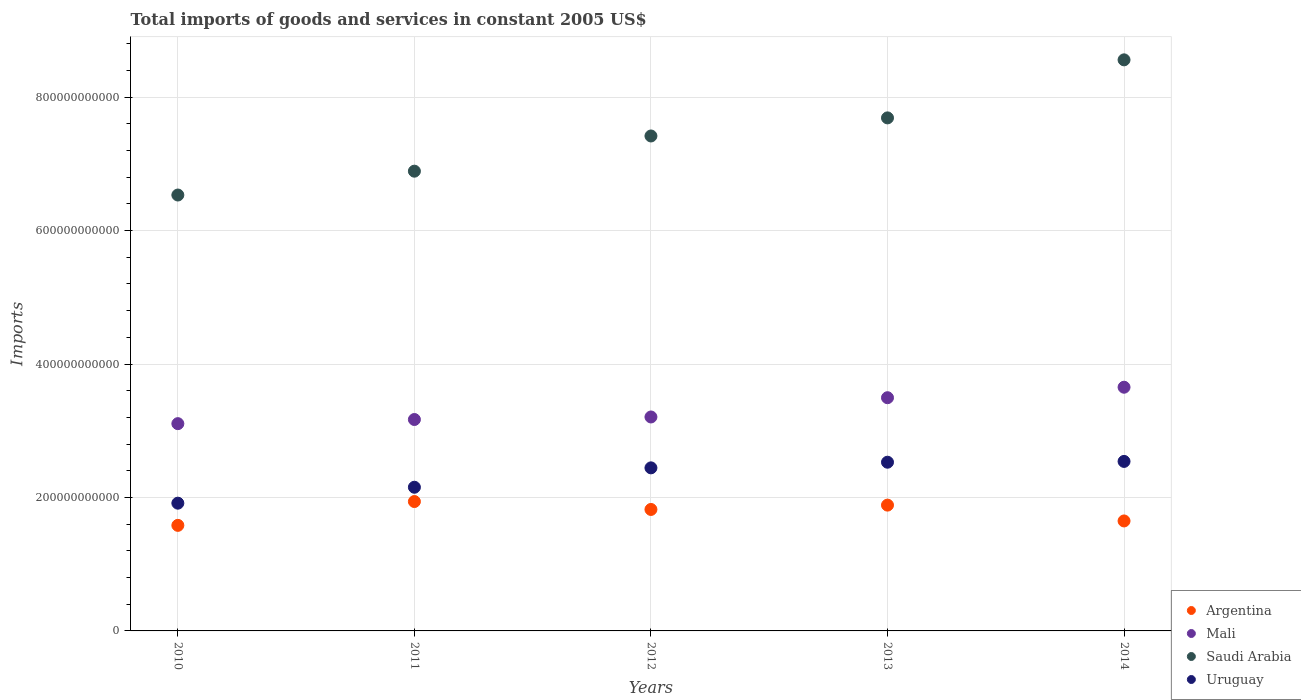Is the number of dotlines equal to the number of legend labels?
Offer a terse response. Yes. What is the total imports of goods and services in Mali in 2013?
Your response must be concise. 3.49e+11. Across all years, what is the maximum total imports of goods and services in Argentina?
Offer a very short reply. 1.94e+11. Across all years, what is the minimum total imports of goods and services in Uruguay?
Make the answer very short. 1.91e+11. What is the total total imports of goods and services in Saudi Arabia in the graph?
Your answer should be compact. 3.71e+12. What is the difference between the total imports of goods and services in Saudi Arabia in 2011 and that in 2013?
Ensure brevity in your answer.  -7.99e+1. What is the difference between the total imports of goods and services in Mali in 2011 and the total imports of goods and services in Saudi Arabia in 2013?
Your answer should be compact. -4.52e+11. What is the average total imports of goods and services in Argentina per year?
Ensure brevity in your answer.  1.77e+11. In the year 2011, what is the difference between the total imports of goods and services in Argentina and total imports of goods and services in Uruguay?
Offer a terse response. -2.14e+1. What is the ratio of the total imports of goods and services in Saudi Arabia in 2011 to that in 2012?
Keep it short and to the point. 0.93. Is the difference between the total imports of goods and services in Argentina in 2011 and 2014 greater than the difference between the total imports of goods and services in Uruguay in 2011 and 2014?
Your response must be concise. Yes. What is the difference between the highest and the second highest total imports of goods and services in Mali?
Your response must be concise. 1.57e+1. What is the difference between the highest and the lowest total imports of goods and services in Saudi Arabia?
Your answer should be compact. 2.03e+11. In how many years, is the total imports of goods and services in Mali greater than the average total imports of goods and services in Mali taken over all years?
Provide a succinct answer. 2. Is it the case that in every year, the sum of the total imports of goods and services in Saudi Arabia and total imports of goods and services in Uruguay  is greater than the sum of total imports of goods and services in Mali and total imports of goods and services in Argentina?
Keep it short and to the point. Yes. Is it the case that in every year, the sum of the total imports of goods and services in Uruguay and total imports of goods and services in Argentina  is greater than the total imports of goods and services in Mali?
Give a very brief answer. Yes. Does the total imports of goods and services in Argentina monotonically increase over the years?
Keep it short and to the point. No. Is the total imports of goods and services in Argentina strictly greater than the total imports of goods and services in Uruguay over the years?
Keep it short and to the point. No. How many dotlines are there?
Provide a short and direct response. 4. How many years are there in the graph?
Your response must be concise. 5. What is the difference between two consecutive major ticks on the Y-axis?
Your answer should be very brief. 2.00e+11. Does the graph contain grids?
Provide a succinct answer. Yes. How many legend labels are there?
Keep it short and to the point. 4. What is the title of the graph?
Give a very brief answer. Total imports of goods and services in constant 2005 US$. What is the label or title of the X-axis?
Ensure brevity in your answer.  Years. What is the label or title of the Y-axis?
Offer a terse response. Imports. What is the Imports of Argentina in 2010?
Provide a succinct answer. 1.58e+11. What is the Imports in Mali in 2010?
Ensure brevity in your answer.  3.11e+11. What is the Imports of Saudi Arabia in 2010?
Provide a short and direct response. 6.53e+11. What is the Imports in Uruguay in 2010?
Provide a succinct answer. 1.91e+11. What is the Imports of Argentina in 2011?
Give a very brief answer. 1.94e+11. What is the Imports in Mali in 2011?
Provide a succinct answer. 3.17e+11. What is the Imports of Saudi Arabia in 2011?
Offer a very short reply. 6.89e+11. What is the Imports of Uruguay in 2011?
Offer a terse response. 2.15e+11. What is the Imports of Argentina in 2012?
Your answer should be very brief. 1.82e+11. What is the Imports of Mali in 2012?
Give a very brief answer. 3.21e+11. What is the Imports of Saudi Arabia in 2012?
Ensure brevity in your answer.  7.42e+11. What is the Imports of Uruguay in 2012?
Your answer should be very brief. 2.44e+11. What is the Imports of Argentina in 2013?
Give a very brief answer. 1.89e+11. What is the Imports in Mali in 2013?
Your answer should be very brief. 3.49e+11. What is the Imports in Saudi Arabia in 2013?
Your response must be concise. 7.69e+11. What is the Imports of Uruguay in 2013?
Keep it short and to the point. 2.53e+11. What is the Imports of Argentina in 2014?
Keep it short and to the point. 1.65e+11. What is the Imports in Mali in 2014?
Offer a very short reply. 3.65e+11. What is the Imports in Saudi Arabia in 2014?
Offer a very short reply. 8.56e+11. What is the Imports of Uruguay in 2014?
Ensure brevity in your answer.  2.54e+11. Across all years, what is the maximum Imports of Argentina?
Provide a succinct answer. 1.94e+11. Across all years, what is the maximum Imports in Mali?
Your answer should be compact. 3.65e+11. Across all years, what is the maximum Imports in Saudi Arabia?
Your answer should be very brief. 8.56e+11. Across all years, what is the maximum Imports of Uruguay?
Your answer should be very brief. 2.54e+11. Across all years, what is the minimum Imports of Argentina?
Your answer should be very brief. 1.58e+11. Across all years, what is the minimum Imports in Mali?
Ensure brevity in your answer.  3.11e+11. Across all years, what is the minimum Imports of Saudi Arabia?
Your answer should be compact. 6.53e+11. Across all years, what is the minimum Imports of Uruguay?
Make the answer very short. 1.91e+11. What is the total Imports in Argentina in the graph?
Provide a succinct answer. 8.87e+11. What is the total Imports of Mali in the graph?
Ensure brevity in your answer.  1.66e+12. What is the total Imports in Saudi Arabia in the graph?
Provide a succinct answer. 3.71e+12. What is the total Imports of Uruguay in the graph?
Offer a very short reply. 1.16e+12. What is the difference between the Imports of Argentina in 2010 and that in 2011?
Provide a succinct answer. -3.57e+1. What is the difference between the Imports of Mali in 2010 and that in 2011?
Keep it short and to the point. -6.21e+09. What is the difference between the Imports in Saudi Arabia in 2010 and that in 2011?
Ensure brevity in your answer.  -3.57e+1. What is the difference between the Imports in Uruguay in 2010 and that in 2011?
Offer a terse response. -2.39e+1. What is the difference between the Imports of Argentina in 2010 and that in 2012?
Provide a short and direct response. -2.38e+1. What is the difference between the Imports in Mali in 2010 and that in 2012?
Your answer should be very brief. -1.00e+1. What is the difference between the Imports of Saudi Arabia in 2010 and that in 2012?
Provide a succinct answer. -8.85e+1. What is the difference between the Imports of Uruguay in 2010 and that in 2012?
Ensure brevity in your answer.  -5.29e+1. What is the difference between the Imports of Argentina in 2010 and that in 2013?
Ensure brevity in your answer.  -3.03e+1. What is the difference between the Imports in Mali in 2010 and that in 2013?
Offer a terse response. -3.89e+1. What is the difference between the Imports of Saudi Arabia in 2010 and that in 2013?
Provide a short and direct response. -1.16e+11. What is the difference between the Imports in Uruguay in 2010 and that in 2013?
Provide a succinct answer. -6.14e+1. What is the difference between the Imports of Argentina in 2010 and that in 2014?
Your response must be concise. -6.62e+09. What is the difference between the Imports of Mali in 2010 and that in 2014?
Provide a short and direct response. -5.46e+1. What is the difference between the Imports of Saudi Arabia in 2010 and that in 2014?
Keep it short and to the point. -2.03e+11. What is the difference between the Imports in Uruguay in 2010 and that in 2014?
Offer a terse response. -6.26e+1. What is the difference between the Imports of Argentina in 2011 and that in 2012?
Your answer should be compact. 1.19e+1. What is the difference between the Imports of Mali in 2011 and that in 2012?
Provide a succinct answer. -3.80e+09. What is the difference between the Imports in Saudi Arabia in 2011 and that in 2012?
Your response must be concise. -5.28e+1. What is the difference between the Imports of Uruguay in 2011 and that in 2012?
Keep it short and to the point. -2.91e+1. What is the difference between the Imports in Argentina in 2011 and that in 2013?
Offer a very short reply. 5.37e+09. What is the difference between the Imports of Mali in 2011 and that in 2013?
Make the answer very short. -3.27e+1. What is the difference between the Imports in Saudi Arabia in 2011 and that in 2013?
Give a very brief answer. -7.99e+1. What is the difference between the Imports in Uruguay in 2011 and that in 2013?
Your answer should be very brief. -3.75e+1. What is the difference between the Imports in Argentina in 2011 and that in 2014?
Give a very brief answer. 2.91e+1. What is the difference between the Imports in Mali in 2011 and that in 2014?
Your answer should be compact. -4.84e+1. What is the difference between the Imports of Saudi Arabia in 2011 and that in 2014?
Keep it short and to the point. -1.67e+11. What is the difference between the Imports in Uruguay in 2011 and that in 2014?
Keep it short and to the point. -3.87e+1. What is the difference between the Imports in Argentina in 2012 and that in 2013?
Give a very brief answer. -6.49e+09. What is the difference between the Imports of Mali in 2012 and that in 2013?
Your response must be concise. -2.89e+1. What is the difference between the Imports of Saudi Arabia in 2012 and that in 2013?
Your response must be concise. -2.71e+1. What is the difference between the Imports of Uruguay in 2012 and that in 2013?
Offer a terse response. -8.46e+09. What is the difference between the Imports in Argentina in 2012 and that in 2014?
Your answer should be compact. 1.72e+1. What is the difference between the Imports of Mali in 2012 and that in 2014?
Provide a short and direct response. -4.46e+1. What is the difference between the Imports of Saudi Arabia in 2012 and that in 2014?
Your answer should be compact. -1.14e+11. What is the difference between the Imports in Uruguay in 2012 and that in 2014?
Your answer should be compact. -9.66e+09. What is the difference between the Imports of Argentina in 2013 and that in 2014?
Make the answer very short. 2.37e+1. What is the difference between the Imports in Mali in 2013 and that in 2014?
Your answer should be very brief. -1.57e+1. What is the difference between the Imports of Saudi Arabia in 2013 and that in 2014?
Make the answer very short. -8.70e+1. What is the difference between the Imports in Uruguay in 2013 and that in 2014?
Provide a succinct answer. -1.20e+09. What is the difference between the Imports in Argentina in 2010 and the Imports in Mali in 2011?
Provide a succinct answer. -1.59e+11. What is the difference between the Imports of Argentina in 2010 and the Imports of Saudi Arabia in 2011?
Your response must be concise. -5.31e+11. What is the difference between the Imports in Argentina in 2010 and the Imports in Uruguay in 2011?
Your response must be concise. -5.71e+1. What is the difference between the Imports of Mali in 2010 and the Imports of Saudi Arabia in 2011?
Keep it short and to the point. -3.78e+11. What is the difference between the Imports of Mali in 2010 and the Imports of Uruguay in 2011?
Provide a short and direct response. 9.53e+1. What is the difference between the Imports of Saudi Arabia in 2010 and the Imports of Uruguay in 2011?
Keep it short and to the point. 4.38e+11. What is the difference between the Imports in Argentina in 2010 and the Imports in Mali in 2012?
Ensure brevity in your answer.  -1.62e+11. What is the difference between the Imports of Argentina in 2010 and the Imports of Saudi Arabia in 2012?
Your answer should be compact. -5.84e+11. What is the difference between the Imports of Argentina in 2010 and the Imports of Uruguay in 2012?
Your response must be concise. -8.62e+1. What is the difference between the Imports in Mali in 2010 and the Imports in Saudi Arabia in 2012?
Provide a short and direct response. -4.31e+11. What is the difference between the Imports of Mali in 2010 and the Imports of Uruguay in 2012?
Offer a terse response. 6.62e+1. What is the difference between the Imports in Saudi Arabia in 2010 and the Imports in Uruguay in 2012?
Your response must be concise. 4.09e+11. What is the difference between the Imports in Argentina in 2010 and the Imports in Mali in 2013?
Give a very brief answer. -1.91e+11. What is the difference between the Imports of Argentina in 2010 and the Imports of Saudi Arabia in 2013?
Ensure brevity in your answer.  -6.11e+11. What is the difference between the Imports of Argentina in 2010 and the Imports of Uruguay in 2013?
Keep it short and to the point. -9.46e+1. What is the difference between the Imports of Mali in 2010 and the Imports of Saudi Arabia in 2013?
Offer a very short reply. -4.58e+11. What is the difference between the Imports of Mali in 2010 and the Imports of Uruguay in 2013?
Your response must be concise. 5.78e+1. What is the difference between the Imports in Saudi Arabia in 2010 and the Imports in Uruguay in 2013?
Offer a terse response. 4.00e+11. What is the difference between the Imports of Argentina in 2010 and the Imports of Mali in 2014?
Make the answer very short. -2.07e+11. What is the difference between the Imports in Argentina in 2010 and the Imports in Saudi Arabia in 2014?
Provide a succinct answer. -6.98e+11. What is the difference between the Imports of Argentina in 2010 and the Imports of Uruguay in 2014?
Provide a succinct answer. -9.58e+1. What is the difference between the Imports in Mali in 2010 and the Imports in Saudi Arabia in 2014?
Offer a very short reply. -5.45e+11. What is the difference between the Imports in Mali in 2010 and the Imports in Uruguay in 2014?
Provide a succinct answer. 5.66e+1. What is the difference between the Imports of Saudi Arabia in 2010 and the Imports of Uruguay in 2014?
Offer a terse response. 3.99e+11. What is the difference between the Imports of Argentina in 2011 and the Imports of Mali in 2012?
Provide a short and direct response. -1.27e+11. What is the difference between the Imports in Argentina in 2011 and the Imports in Saudi Arabia in 2012?
Provide a succinct answer. -5.48e+11. What is the difference between the Imports in Argentina in 2011 and the Imports in Uruguay in 2012?
Your answer should be compact. -5.05e+1. What is the difference between the Imports in Mali in 2011 and the Imports in Saudi Arabia in 2012?
Make the answer very short. -4.25e+11. What is the difference between the Imports of Mali in 2011 and the Imports of Uruguay in 2012?
Provide a short and direct response. 7.25e+1. What is the difference between the Imports of Saudi Arabia in 2011 and the Imports of Uruguay in 2012?
Your answer should be compact. 4.45e+11. What is the difference between the Imports of Argentina in 2011 and the Imports of Mali in 2013?
Offer a terse response. -1.56e+11. What is the difference between the Imports of Argentina in 2011 and the Imports of Saudi Arabia in 2013?
Provide a short and direct response. -5.75e+11. What is the difference between the Imports of Argentina in 2011 and the Imports of Uruguay in 2013?
Offer a very short reply. -5.89e+1. What is the difference between the Imports in Mali in 2011 and the Imports in Saudi Arabia in 2013?
Provide a short and direct response. -4.52e+11. What is the difference between the Imports of Mali in 2011 and the Imports of Uruguay in 2013?
Make the answer very short. 6.40e+1. What is the difference between the Imports of Saudi Arabia in 2011 and the Imports of Uruguay in 2013?
Offer a very short reply. 4.36e+11. What is the difference between the Imports of Argentina in 2011 and the Imports of Mali in 2014?
Your response must be concise. -1.71e+11. What is the difference between the Imports of Argentina in 2011 and the Imports of Saudi Arabia in 2014?
Your answer should be very brief. -6.62e+11. What is the difference between the Imports of Argentina in 2011 and the Imports of Uruguay in 2014?
Ensure brevity in your answer.  -6.01e+1. What is the difference between the Imports in Mali in 2011 and the Imports in Saudi Arabia in 2014?
Provide a short and direct response. -5.39e+11. What is the difference between the Imports of Mali in 2011 and the Imports of Uruguay in 2014?
Your answer should be very brief. 6.28e+1. What is the difference between the Imports of Saudi Arabia in 2011 and the Imports of Uruguay in 2014?
Make the answer very short. 4.35e+11. What is the difference between the Imports in Argentina in 2012 and the Imports in Mali in 2013?
Your answer should be very brief. -1.67e+11. What is the difference between the Imports of Argentina in 2012 and the Imports of Saudi Arabia in 2013?
Give a very brief answer. -5.87e+11. What is the difference between the Imports of Argentina in 2012 and the Imports of Uruguay in 2013?
Give a very brief answer. -7.08e+1. What is the difference between the Imports of Mali in 2012 and the Imports of Saudi Arabia in 2013?
Provide a succinct answer. -4.48e+11. What is the difference between the Imports of Mali in 2012 and the Imports of Uruguay in 2013?
Ensure brevity in your answer.  6.78e+1. What is the difference between the Imports in Saudi Arabia in 2012 and the Imports in Uruguay in 2013?
Your response must be concise. 4.89e+11. What is the difference between the Imports of Argentina in 2012 and the Imports of Mali in 2014?
Ensure brevity in your answer.  -1.83e+11. What is the difference between the Imports of Argentina in 2012 and the Imports of Saudi Arabia in 2014?
Provide a succinct answer. -6.74e+11. What is the difference between the Imports in Argentina in 2012 and the Imports in Uruguay in 2014?
Your response must be concise. -7.20e+1. What is the difference between the Imports of Mali in 2012 and the Imports of Saudi Arabia in 2014?
Your response must be concise. -5.35e+11. What is the difference between the Imports of Mali in 2012 and the Imports of Uruguay in 2014?
Offer a terse response. 6.66e+1. What is the difference between the Imports of Saudi Arabia in 2012 and the Imports of Uruguay in 2014?
Provide a succinct answer. 4.88e+11. What is the difference between the Imports in Argentina in 2013 and the Imports in Mali in 2014?
Provide a succinct answer. -1.77e+11. What is the difference between the Imports in Argentina in 2013 and the Imports in Saudi Arabia in 2014?
Offer a very short reply. -6.67e+11. What is the difference between the Imports of Argentina in 2013 and the Imports of Uruguay in 2014?
Offer a very short reply. -6.55e+1. What is the difference between the Imports of Mali in 2013 and the Imports of Saudi Arabia in 2014?
Ensure brevity in your answer.  -5.06e+11. What is the difference between the Imports in Mali in 2013 and the Imports in Uruguay in 2014?
Make the answer very short. 9.55e+1. What is the difference between the Imports in Saudi Arabia in 2013 and the Imports in Uruguay in 2014?
Provide a short and direct response. 5.15e+11. What is the average Imports in Argentina per year?
Ensure brevity in your answer.  1.77e+11. What is the average Imports of Mali per year?
Your answer should be compact. 3.33e+11. What is the average Imports in Saudi Arabia per year?
Ensure brevity in your answer.  7.42e+11. What is the average Imports in Uruguay per year?
Your answer should be very brief. 2.32e+11. In the year 2010, what is the difference between the Imports in Argentina and Imports in Mali?
Your answer should be very brief. -1.52e+11. In the year 2010, what is the difference between the Imports in Argentina and Imports in Saudi Arabia?
Offer a terse response. -4.95e+11. In the year 2010, what is the difference between the Imports in Argentina and Imports in Uruguay?
Ensure brevity in your answer.  -3.33e+1. In the year 2010, what is the difference between the Imports in Mali and Imports in Saudi Arabia?
Provide a short and direct response. -3.43e+11. In the year 2010, what is the difference between the Imports of Mali and Imports of Uruguay?
Offer a very short reply. 1.19e+11. In the year 2010, what is the difference between the Imports of Saudi Arabia and Imports of Uruguay?
Keep it short and to the point. 4.62e+11. In the year 2011, what is the difference between the Imports of Argentina and Imports of Mali?
Provide a short and direct response. -1.23e+11. In the year 2011, what is the difference between the Imports in Argentina and Imports in Saudi Arabia?
Give a very brief answer. -4.95e+11. In the year 2011, what is the difference between the Imports of Argentina and Imports of Uruguay?
Your response must be concise. -2.14e+1. In the year 2011, what is the difference between the Imports of Mali and Imports of Saudi Arabia?
Your answer should be very brief. -3.72e+11. In the year 2011, what is the difference between the Imports of Mali and Imports of Uruguay?
Provide a short and direct response. 1.02e+11. In the year 2011, what is the difference between the Imports of Saudi Arabia and Imports of Uruguay?
Offer a very short reply. 4.74e+11. In the year 2012, what is the difference between the Imports of Argentina and Imports of Mali?
Provide a short and direct response. -1.39e+11. In the year 2012, what is the difference between the Imports in Argentina and Imports in Saudi Arabia?
Your response must be concise. -5.60e+11. In the year 2012, what is the difference between the Imports in Argentina and Imports in Uruguay?
Offer a very short reply. -6.23e+1. In the year 2012, what is the difference between the Imports in Mali and Imports in Saudi Arabia?
Ensure brevity in your answer.  -4.21e+11. In the year 2012, what is the difference between the Imports in Mali and Imports in Uruguay?
Make the answer very short. 7.63e+1. In the year 2012, what is the difference between the Imports in Saudi Arabia and Imports in Uruguay?
Give a very brief answer. 4.97e+11. In the year 2013, what is the difference between the Imports of Argentina and Imports of Mali?
Provide a succinct answer. -1.61e+11. In the year 2013, what is the difference between the Imports in Argentina and Imports in Saudi Arabia?
Offer a terse response. -5.80e+11. In the year 2013, what is the difference between the Imports in Argentina and Imports in Uruguay?
Keep it short and to the point. -6.43e+1. In the year 2013, what is the difference between the Imports of Mali and Imports of Saudi Arabia?
Keep it short and to the point. -4.19e+11. In the year 2013, what is the difference between the Imports in Mali and Imports in Uruguay?
Ensure brevity in your answer.  9.67e+1. In the year 2013, what is the difference between the Imports in Saudi Arabia and Imports in Uruguay?
Your answer should be compact. 5.16e+11. In the year 2014, what is the difference between the Imports in Argentina and Imports in Mali?
Give a very brief answer. -2.00e+11. In the year 2014, what is the difference between the Imports of Argentina and Imports of Saudi Arabia?
Give a very brief answer. -6.91e+11. In the year 2014, what is the difference between the Imports of Argentina and Imports of Uruguay?
Offer a terse response. -8.92e+1. In the year 2014, what is the difference between the Imports of Mali and Imports of Saudi Arabia?
Offer a terse response. -4.91e+11. In the year 2014, what is the difference between the Imports of Mali and Imports of Uruguay?
Offer a very short reply. 1.11e+11. In the year 2014, what is the difference between the Imports in Saudi Arabia and Imports in Uruguay?
Give a very brief answer. 6.02e+11. What is the ratio of the Imports of Argentina in 2010 to that in 2011?
Keep it short and to the point. 0.82. What is the ratio of the Imports of Mali in 2010 to that in 2011?
Provide a succinct answer. 0.98. What is the ratio of the Imports in Saudi Arabia in 2010 to that in 2011?
Ensure brevity in your answer.  0.95. What is the ratio of the Imports of Uruguay in 2010 to that in 2011?
Your answer should be very brief. 0.89. What is the ratio of the Imports of Argentina in 2010 to that in 2012?
Ensure brevity in your answer.  0.87. What is the ratio of the Imports of Mali in 2010 to that in 2012?
Give a very brief answer. 0.97. What is the ratio of the Imports in Saudi Arabia in 2010 to that in 2012?
Your response must be concise. 0.88. What is the ratio of the Imports in Uruguay in 2010 to that in 2012?
Give a very brief answer. 0.78. What is the ratio of the Imports of Argentina in 2010 to that in 2013?
Offer a terse response. 0.84. What is the ratio of the Imports of Mali in 2010 to that in 2013?
Give a very brief answer. 0.89. What is the ratio of the Imports of Saudi Arabia in 2010 to that in 2013?
Ensure brevity in your answer.  0.85. What is the ratio of the Imports of Uruguay in 2010 to that in 2013?
Provide a short and direct response. 0.76. What is the ratio of the Imports in Argentina in 2010 to that in 2014?
Your answer should be compact. 0.96. What is the ratio of the Imports in Mali in 2010 to that in 2014?
Keep it short and to the point. 0.85. What is the ratio of the Imports in Saudi Arabia in 2010 to that in 2014?
Offer a terse response. 0.76. What is the ratio of the Imports of Uruguay in 2010 to that in 2014?
Offer a very short reply. 0.75. What is the ratio of the Imports in Argentina in 2011 to that in 2012?
Offer a terse response. 1.07. What is the ratio of the Imports of Saudi Arabia in 2011 to that in 2012?
Keep it short and to the point. 0.93. What is the ratio of the Imports of Uruguay in 2011 to that in 2012?
Offer a very short reply. 0.88. What is the ratio of the Imports in Argentina in 2011 to that in 2013?
Offer a very short reply. 1.03. What is the ratio of the Imports of Mali in 2011 to that in 2013?
Your response must be concise. 0.91. What is the ratio of the Imports in Saudi Arabia in 2011 to that in 2013?
Make the answer very short. 0.9. What is the ratio of the Imports of Uruguay in 2011 to that in 2013?
Your answer should be compact. 0.85. What is the ratio of the Imports in Argentina in 2011 to that in 2014?
Ensure brevity in your answer.  1.18. What is the ratio of the Imports in Mali in 2011 to that in 2014?
Offer a terse response. 0.87. What is the ratio of the Imports of Saudi Arabia in 2011 to that in 2014?
Provide a short and direct response. 0.81. What is the ratio of the Imports of Uruguay in 2011 to that in 2014?
Your answer should be very brief. 0.85. What is the ratio of the Imports in Argentina in 2012 to that in 2013?
Give a very brief answer. 0.97. What is the ratio of the Imports of Mali in 2012 to that in 2013?
Give a very brief answer. 0.92. What is the ratio of the Imports in Saudi Arabia in 2012 to that in 2013?
Your answer should be very brief. 0.96. What is the ratio of the Imports in Uruguay in 2012 to that in 2013?
Ensure brevity in your answer.  0.97. What is the ratio of the Imports in Argentina in 2012 to that in 2014?
Offer a terse response. 1.1. What is the ratio of the Imports in Mali in 2012 to that in 2014?
Ensure brevity in your answer.  0.88. What is the ratio of the Imports in Saudi Arabia in 2012 to that in 2014?
Your answer should be very brief. 0.87. What is the ratio of the Imports in Uruguay in 2012 to that in 2014?
Offer a terse response. 0.96. What is the ratio of the Imports of Argentina in 2013 to that in 2014?
Offer a very short reply. 1.14. What is the ratio of the Imports of Mali in 2013 to that in 2014?
Provide a short and direct response. 0.96. What is the ratio of the Imports in Saudi Arabia in 2013 to that in 2014?
Provide a short and direct response. 0.9. What is the ratio of the Imports of Uruguay in 2013 to that in 2014?
Ensure brevity in your answer.  1. What is the difference between the highest and the second highest Imports of Argentina?
Give a very brief answer. 5.37e+09. What is the difference between the highest and the second highest Imports in Mali?
Provide a succinct answer. 1.57e+1. What is the difference between the highest and the second highest Imports in Saudi Arabia?
Your answer should be compact. 8.70e+1. What is the difference between the highest and the second highest Imports in Uruguay?
Give a very brief answer. 1.20e+09. What is the difference between the highest and the lowest Imports in Argentina?
Provide a short and direct response. 3.57e+1. What is the difference between the highest and the lowest Imports in Mali?
Your answer should be compact. 5.46e+1. What is the difference between the highest and the lowest Imports in Saudi Arabia?
Ensure brevity in your answer.  2.03e+11. What is the difference between the highest and the lowest Imports of Uruguay?
Offer a terse response. 6.26e+1. 